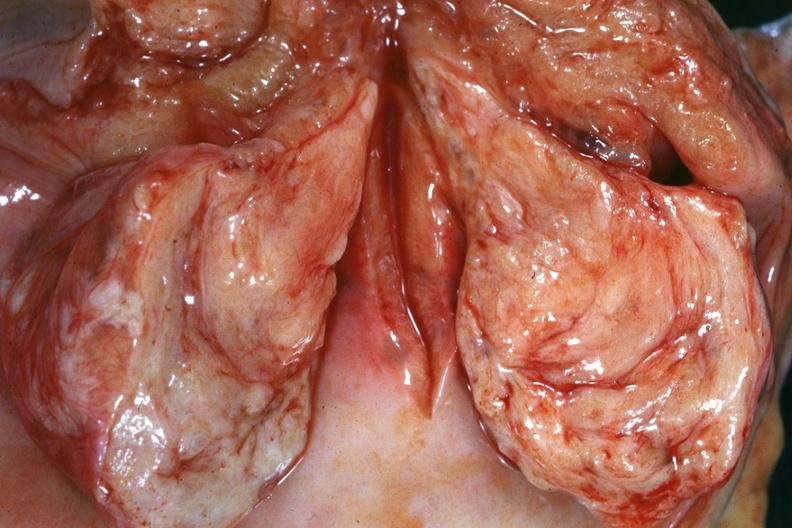does this image show close-up of cut surface of cervical myoma which is shown in relation to cervix and vagina?
Answer the question using a single word or phrase. Yes 